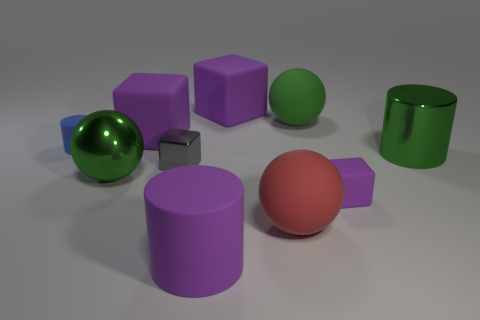What size is the blue matte thing?
Offer a terse response. Small. There is a big cylinder that is on the left side of the metallic cylinder; is its color the same as the tiny thing to the right of the tiny gray block?
Keep it short and to the point. Yes. How many other things are there of the same material as the large red ball?
Your answer should be very brief. 6. Are any gray things visible?
Your response must be concise. Yes. Is the material of the purple thing that is on the right side of the big red rubber sphere the same as the large purple cylinder?
Provide a short and direct response. Yes. What is the material of the other large green thing that is the same shape as the big green matte thing?
Ensure brevity in your answer.  Metal. What material is the cylinder that is the same color as the metal ball?
Offer a terse response. Metal. Is the number of red things less than the number of tiny cyan shiny cylinders?
Your answer should be very brief. No. Does the big cylinder that is in front of the gray cube have the same color as the small matte block?
Your response must be concise. Yes. There is a large sphere that is the same material as the green cylinder; what color is it?
Keep it short and to the point. Green. 